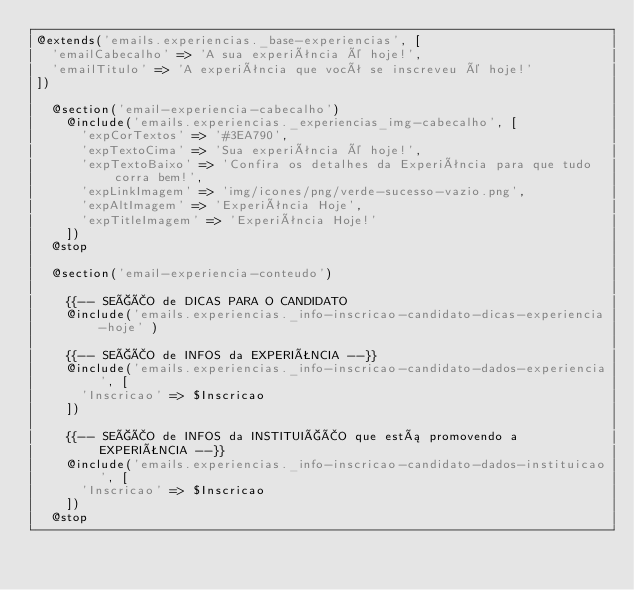Convert code to text. <code><loc_0><loc_0><loc_500><loc_500><_PHP_>@extends('emails.experiencias._base-experiencias', [
  'emailCabecalho' => 'A sua experiência é hoje!',
  'emailTitulo' => 'A experiência que você se inscreveu é hoje!'
])

  @section('email-experiencia-cabecalho')
    @include('emails.experiencias._experiencias_img-cabecalho', [
      'expCorTextos' => '#3EA790',
      'expTextoCima' => 'Sua experiência é hoje!',
      'expTextoBaixo' => 'Confira os detalhes da Experiência para que tudo corra bem!',
      'expLinkImagem' => 'img/icones/png/verde-sucesso-vazio.png',
      'expAltImagem' => 'Experiência Hoje',
      'expTitleImagem' => 'Experiência Hoje!'
    ])
  @stop

  @section('email-experiencia-conteudo')

    {{-- SEÇÃO de DICAS PARA O CANDIDATO
    @include('emails.experiencias._info-inscricao-candidato-dicas-experiencia-hoje' )

    {{-- SEÇÃO de INFOS da EXPERIÊNCIA --}}
    @include('emails.experiencias._info-inscricao-candidato-dados-experiencia', [
      'Inscricao' => $Inscricao
    ])

    {{-- SEÇÃO de INFOS da INSTITUIÇÃO que está promovendo a EXPERIÊNCIA --}}
    @include('emails.experiencias._info-inscricao-candidato-dados-instituicao', [
      'Inscricao' => $Inscricao
    ])
  @stop
</code> 